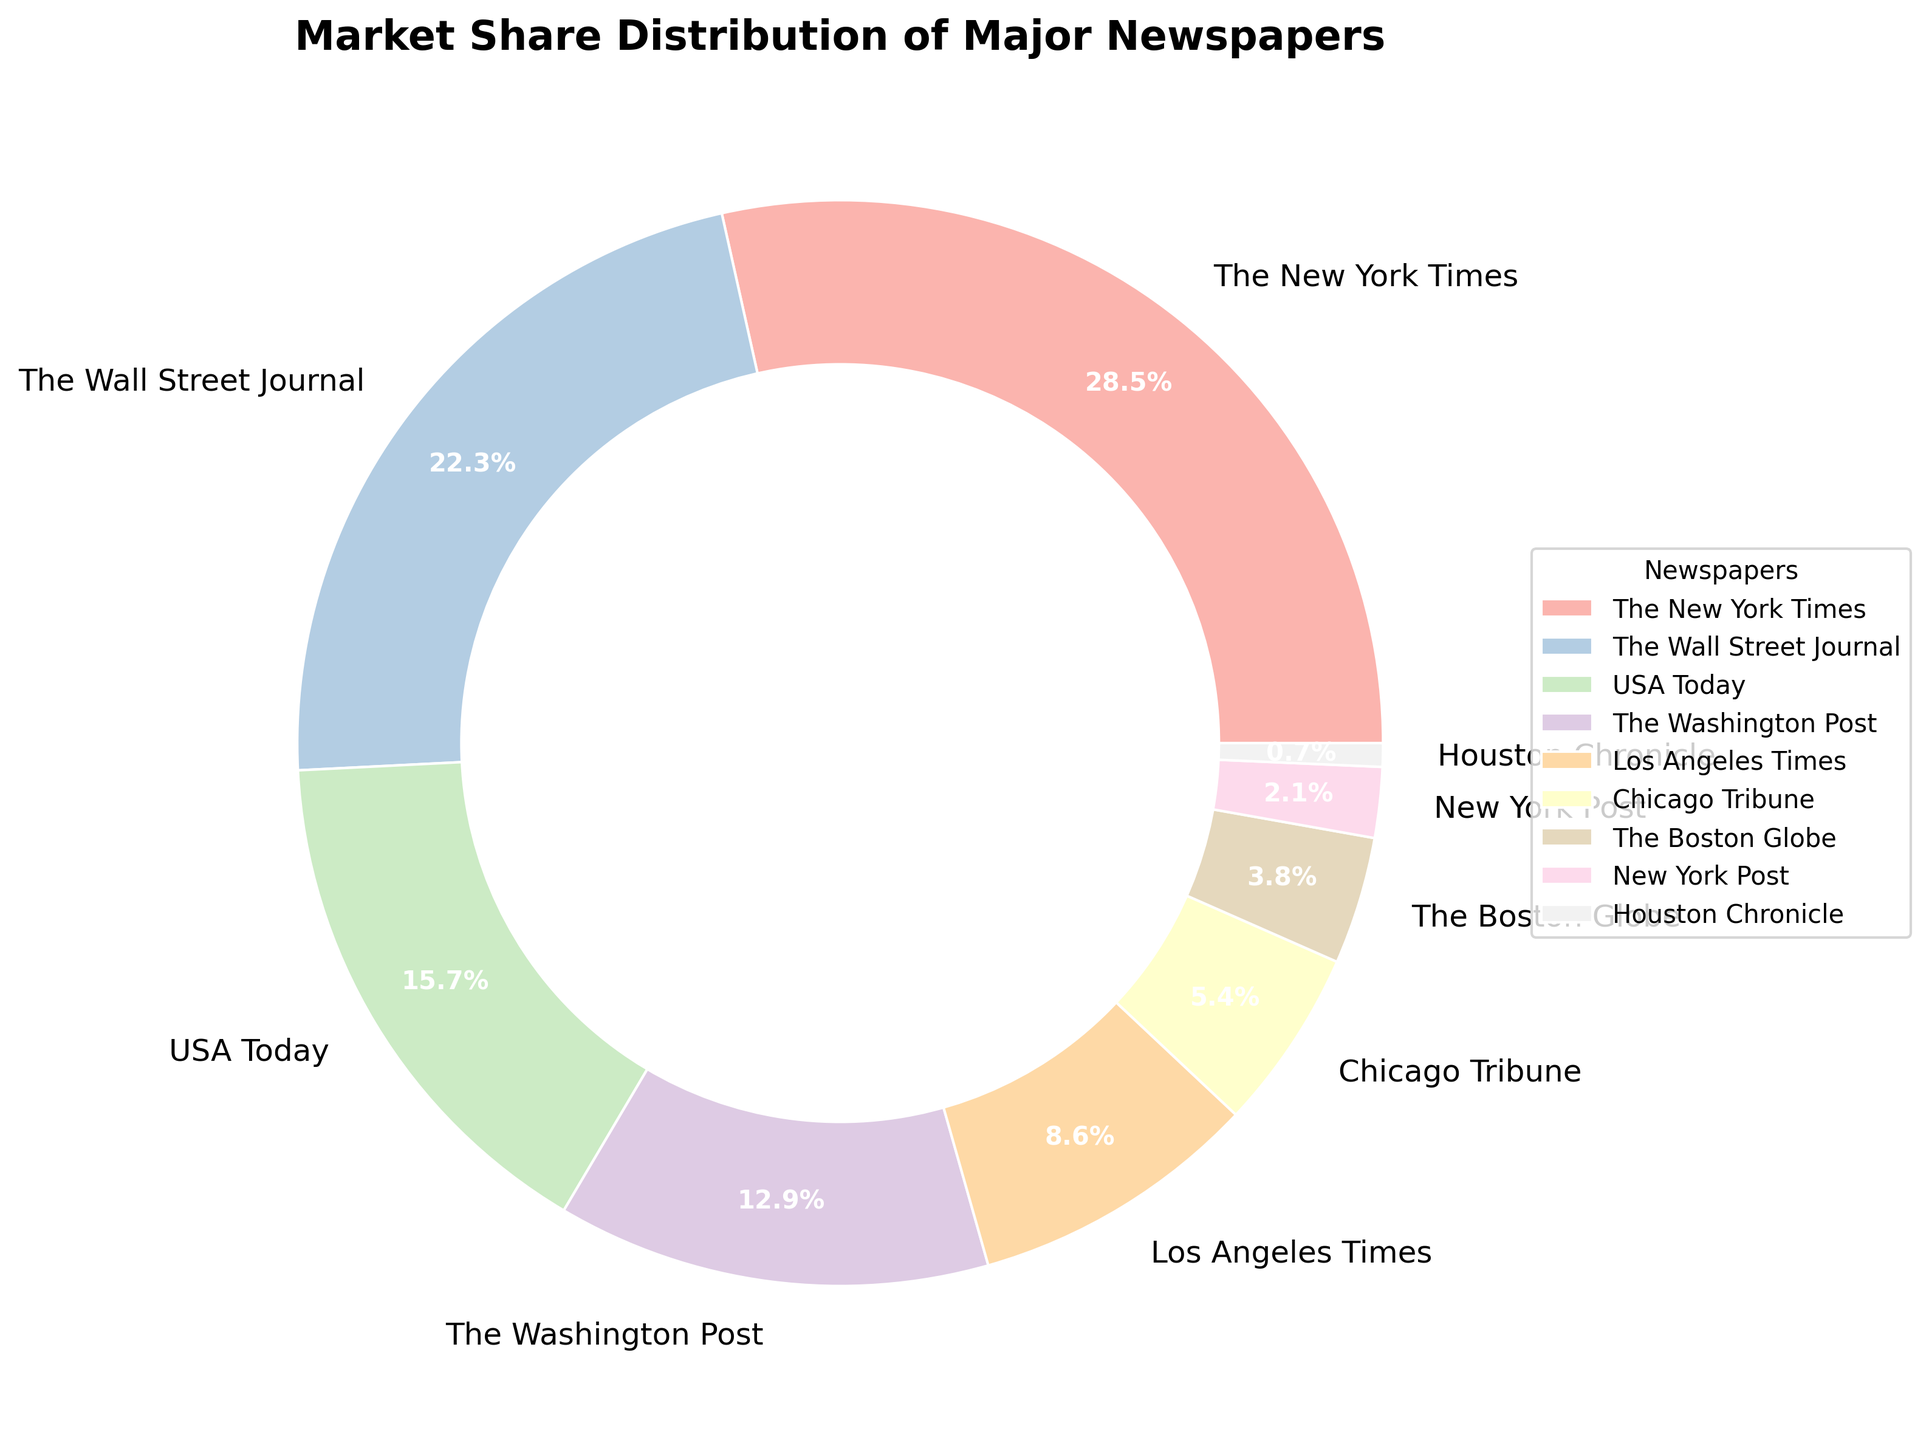What's the market share of The New York Times? The New York Times' market share is a direct value labeled on the pie chart.
Answer: 28.5% Which newspaper has the smallest market share? The smallest value in the chart is labeled as the market share of the Houston Chronicle.
Answer: Houston Chronicle What is the combined market share of The New York Times and The Wall Street Journal? Add the market shares of The New York Times (28.5%) and The Wall Street Journal (22.3%): 28.5 + 22.3 = 50.8.
Answer: 50.8% Which two newspapers together make up exactly half of the total market share? Adding the market shares of The New York Times (28.5%) and The Wall Street Journal (22.3%) equals 50.8%, which is close to half of the total.
Answer: The New York Times and The Wall Street Journal How does USA Today's market share compare to The Wall Street Journal's? The market share of The Wall Street Journal (22.3%) is higher than USA Today's (15.7%).
Answer: The Wall Street Journal's is higher What is the difference in market share between The New York Times and Los Angeles Times? Subtract the market share of Los Angeles Times (8.6%) from that of The New York Times (28.5%): 28.5 - 8.6 = 19.9.
Answer: 19.9% Which newspaper occupies the middle position in terms of market share? The middle position would be the median value in an ordered list; the sorted list has The Washington Post (12.9%) in the middle.
Answer: The Washington Post Is The Washington Post's market share greater than double that of the Chicago Tribune? The Washington Post has 12.9% and the Chicago Tribune has 5.4%; double of 5.4% is 10.8%, and 12.9% > 10.8%.
Answer: Yes Among The Boston Globe, New York Post, and Houston Chronicle, which has the largest market share? Compare their values: Boston Globe (3.8%), New York Post (2.1%), Houston Chronicle (0.7%); The Boston Globe has the largest.
Answer: The Boston Globe What is the total market share of newspapers with a market share below 10%? Add the shares of Los Angeles Times (8.6%), Chicago Tribune (5.4%), The Boston Globe (3.8%), New York Post (2.1%), and Houston Chronicle (0.7%): 8.6 + 5.4 + 3.8 + 2.1 + 0.7 = 20.6%.
Answer: 20.6% 